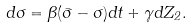Convert formula to latex. <formula><loc_0><loc_0><loc_500><loc_500>d \sigma = \beta ( \bar { \sigma } - \sigma ) d t + \gamma d Z _ { 2 } .</formula> 